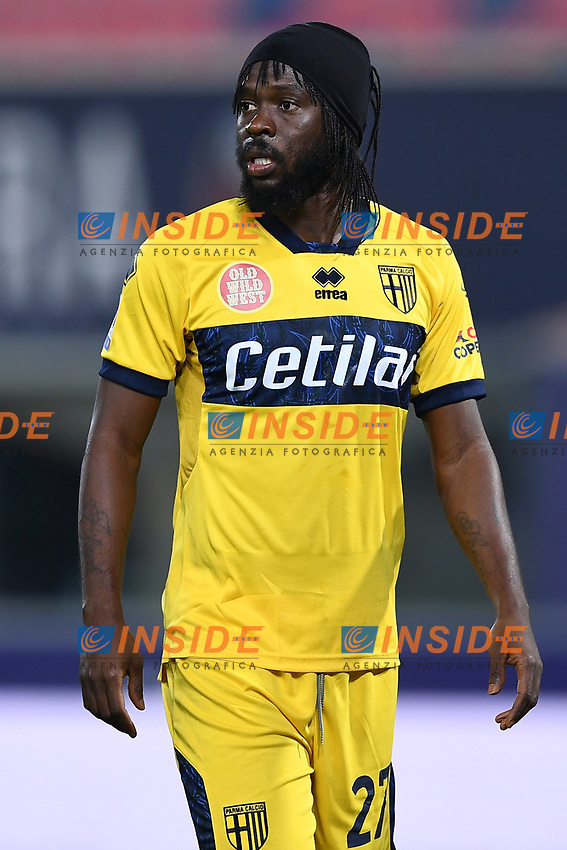Can you describe the significance of the sponsor logo on the jersey? The 'Cetilà' logo on the jersey signifies a sponsorship deal, common in professional sports. The presence of a sponsor logo like this is crucial as it indicates commercial support and enhances the team's financial capabilities. It's also indicative of the team and the sponsor sharing a target audience, suggesting 'Cetilà' is a brand resonating with sports fans, potentially offering products or services aligned with the active, dynamic lifestyle associated with football. 